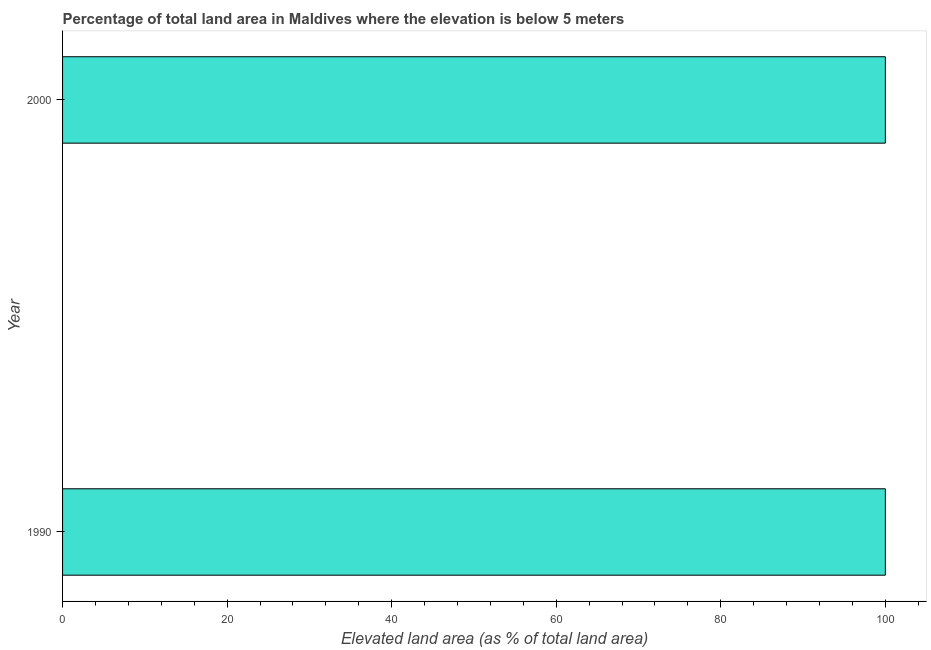Does the graph contain any zero values?
Ensure brevity in your answer.  No. What is the title of the graph?
Provide a succinct answer. Percentage of total land area in Maldives where the elevation is below 5 meters. What is the label or title of the X-axis?
Make the answer very short. Elevated land area (as % of total land area). What is the label or title of the Y-axis?
Keep it short and to the point. Year. What is the total elevated land area in 1990?
Your answer should be very brief. 100. Across all years, what is the maximum total elevated land area?
Provide a short and direct response. 100. Across all years, what is the minimum total elevated land area?
Keep it short and to the point. 100. In which year was the total elevated land area maximum?
Provide a short and direct response. 1990. What is the sum of the total elevated land area?
Provide a short and direct response. 200. What is the median total elevated land area?
Keep it short and to the point. 100. Is the total elevated land area in 1990 less than that in 2000?
Offer a terse response. No. In how many years, is the total elevated land area greater than the average total elevated land area taken over all years?
Give a very brief answer. 0. How many bars are there?
Provide a succinct answer. 2. Are all the bars in the graph horizontal?
Offer a terse response. Yes. How many years are there in the graph?
Ensure brevity in your answer.  2. What is the difference between two consecutive major ticks on the X-axis?
Give a very brief answer. 20. What is the Elevated land area (as % of total land area) of 1990?
Offer a terse response. 100. What is the Elevated land area (as % of total land area) in 2000?
Offer a terse response. 100. What is the ratio of the Elevated land area (as % of total land area) in 1990 to that in 2000?
Keep it short and to the point. 1. 